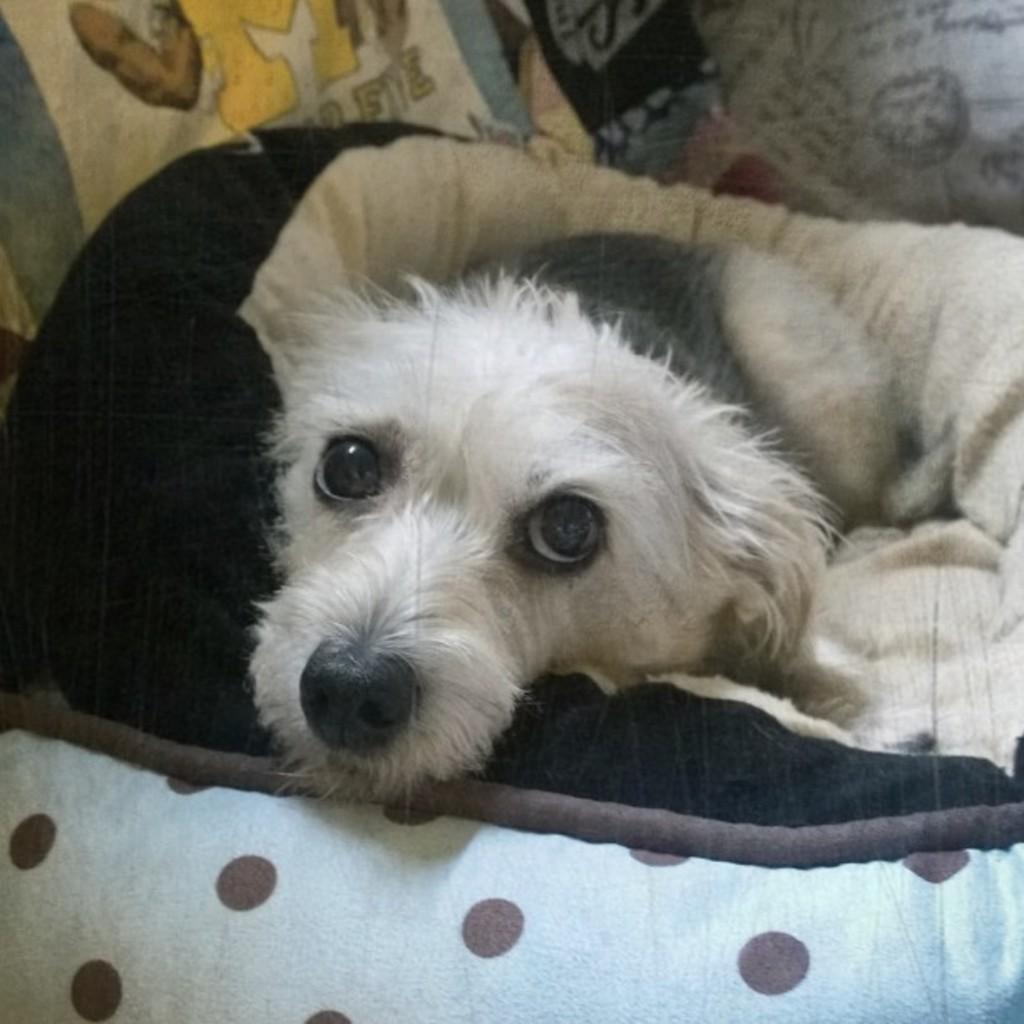Please provide a concise description of this image. In this picture we can see a dog is laying on a cloth, in the background we can see a pillow. 